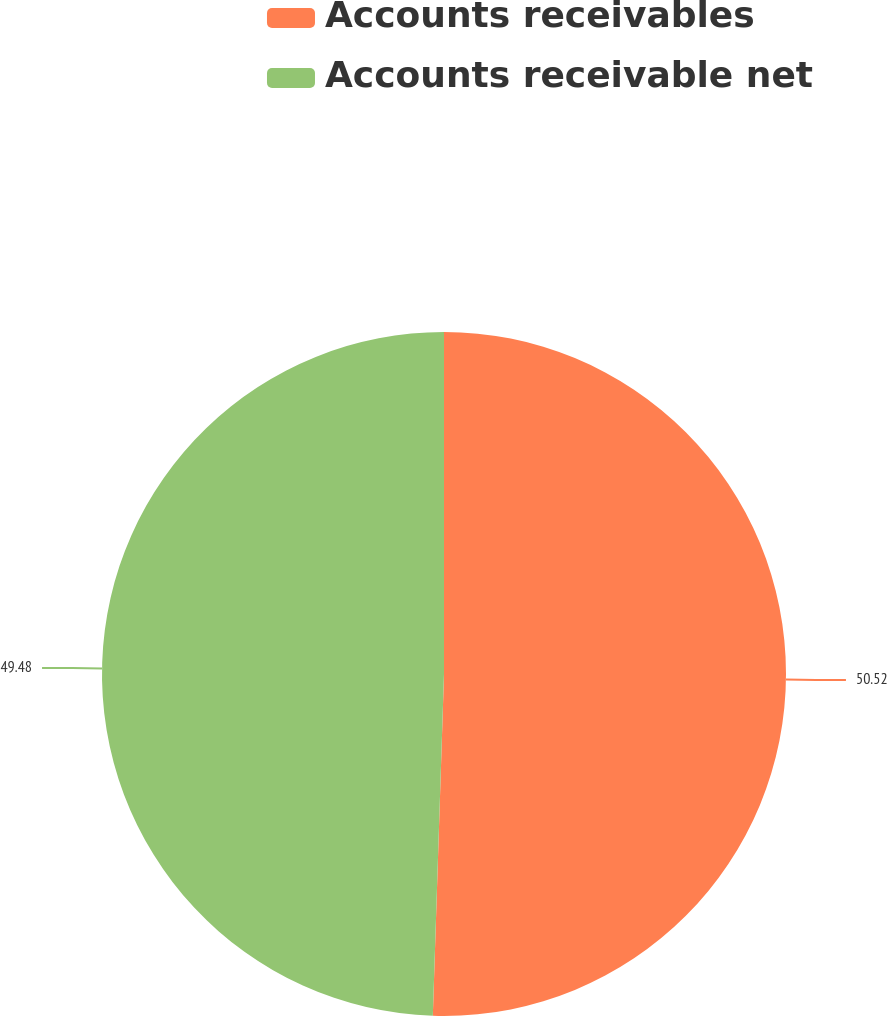<chart> <loc_0><loc_0><loc_500><loc_500><pie_chart><fcel>Accounts receivables<fcel>Accounts receivable net<nl><fcel>50.52%<fcel>49.48%<nl></chart> 